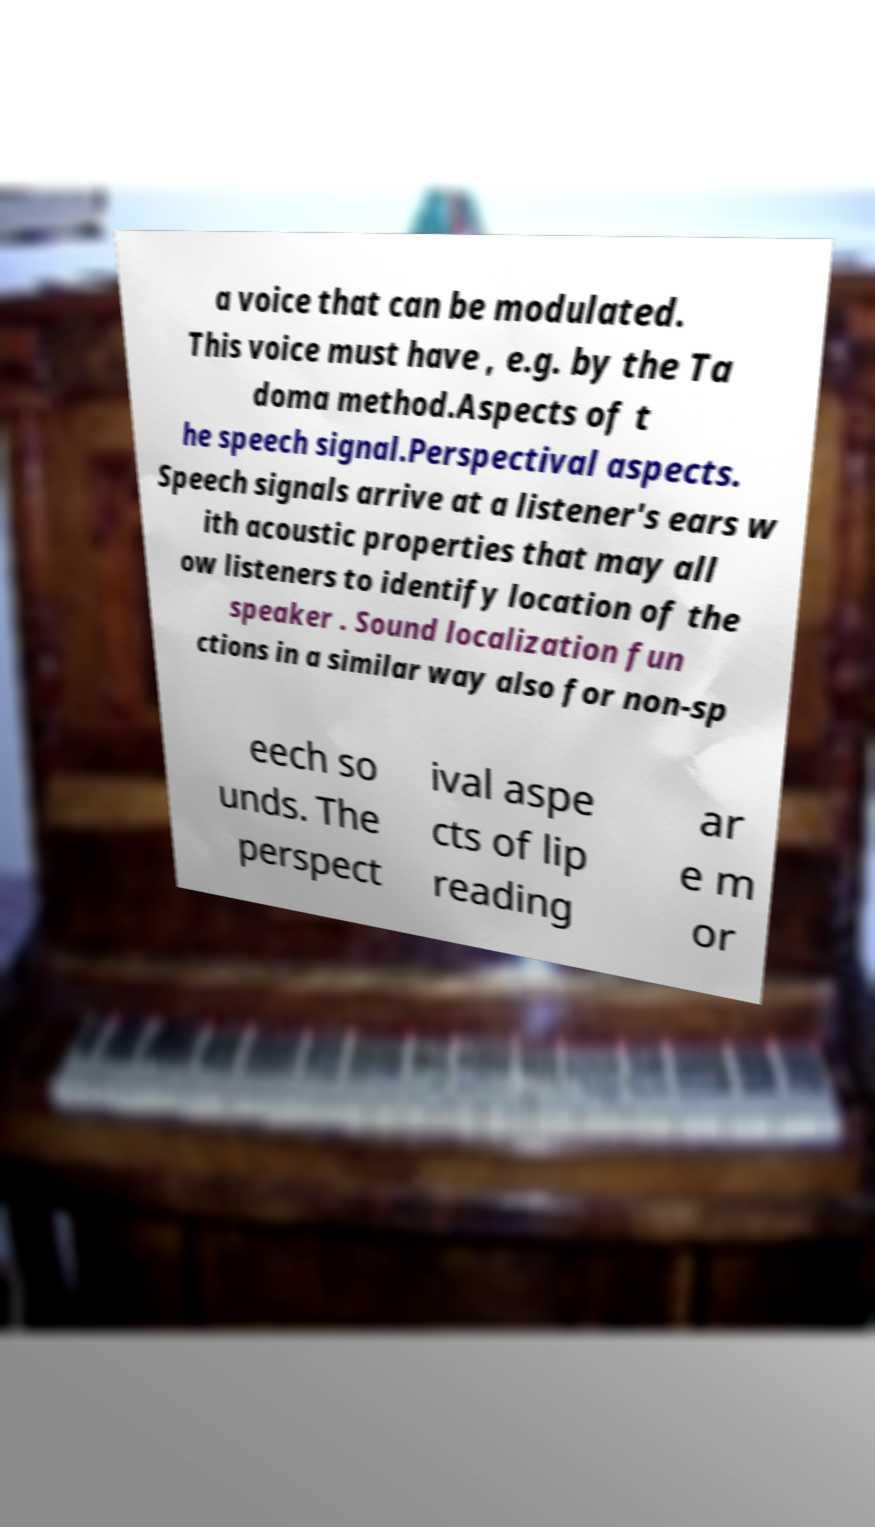Please identify and transcribe the text found in this image. a voice that can be modulated. This voice must have , e.g. by the Ta doma method.Aspects of t he speech signal.Perspectival aspects. Speech signals arrive at a listener's ears w ith acoustic properties that may all ow listeners to identify location of the speaker . Sound localization fun ctions in a similar way also for non-sp eech so unds. The perspect ival aspe cts of lip reading ar e m or 